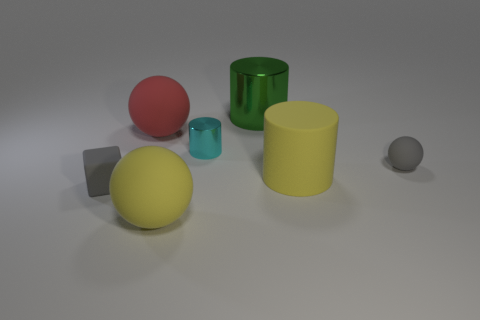Add 2 gray rubber cubes. How many objects exist? 9 Subtract 0 blue cylinders. How many objects are left? 7 Subtract all blocks. How many objects are left? 6 Subtract all large red rubber cylinders. Subtract all cyan objects. How many objects are left? 6 Add 6 small cubes. How many small cubes are left? 7 Add 6 tiny gray objects. How many tiny gray objects exist? 8 